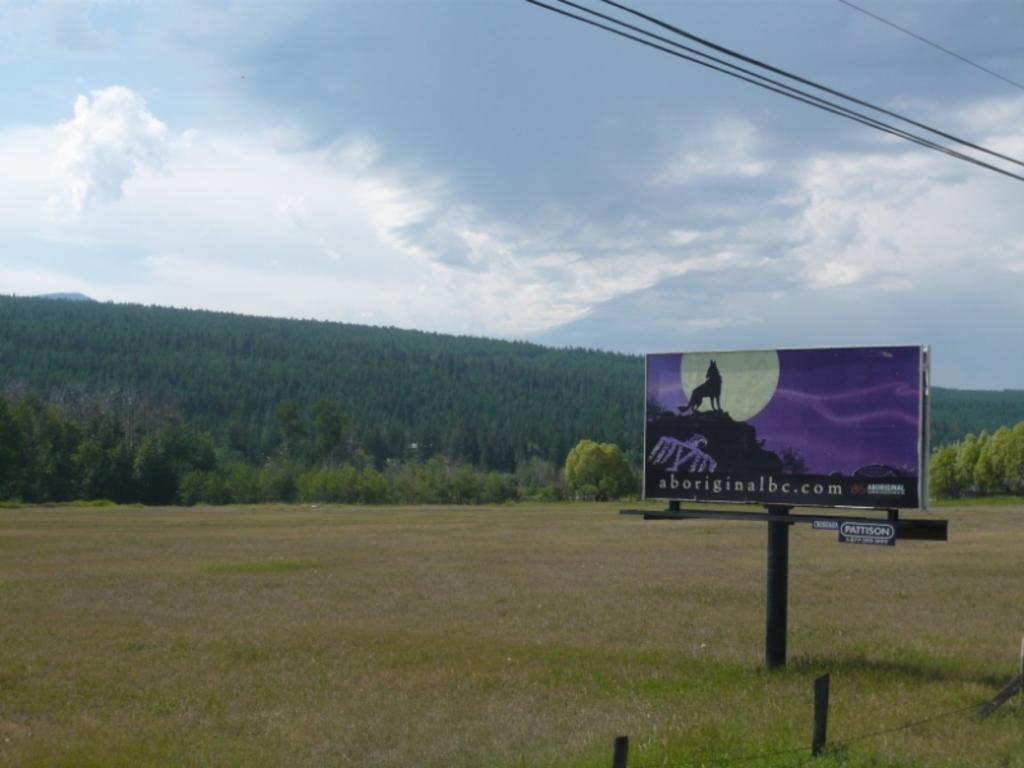Could you give a brief overview of what you see in this image? In the foreground of this image, there is grass land, a fence and a hoarding. At the top, there are cables and the sky. In the background, there are trees. 